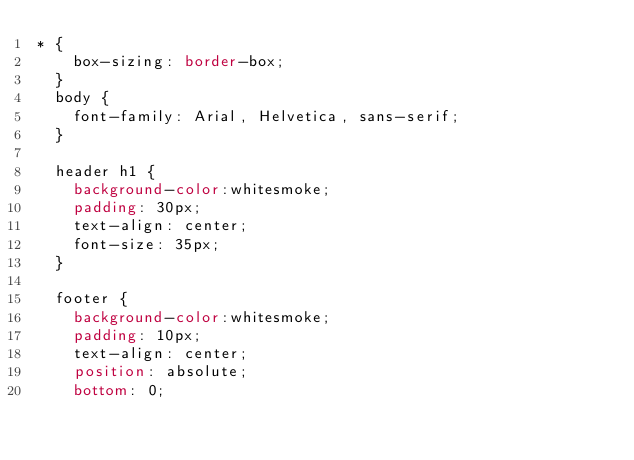<code> <loc_0><loc_0><loc_500><loc_500><_CSS_>* {
    box-sizing: border-box;
  }
  body {
    font-family: Arial, Helvetica, sans-serif;
  }
  
  header h1 {
    background-color:whitesmoke;
    padding: 30px;
    text-align: center;
    font-size: 35px;
  }

  footer {
    background-color:whitesmoke;
    padding: 10px;
    text-align: center;
    position: absolute;
    bottom: 0;</code> 